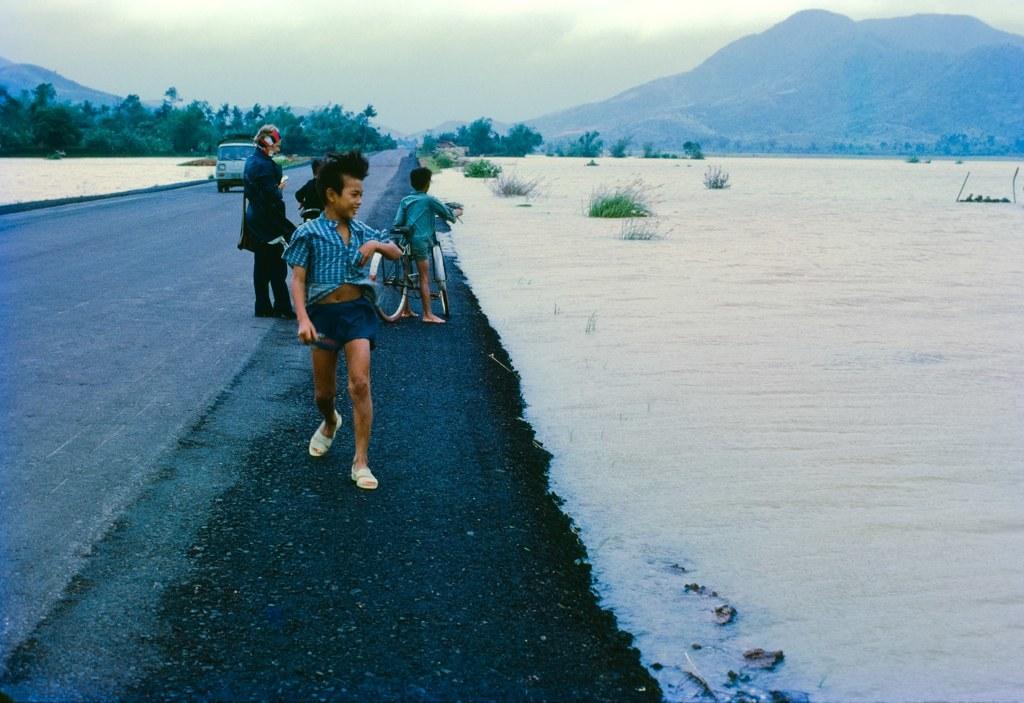Could you give a brief overview of what you see in this image? In this image we can see persons standing on the road and one of them is holding a bicycle. In the background there are sky with clouds, hills, trees, motor vehicle on the road, road covered with snow and bushes. 